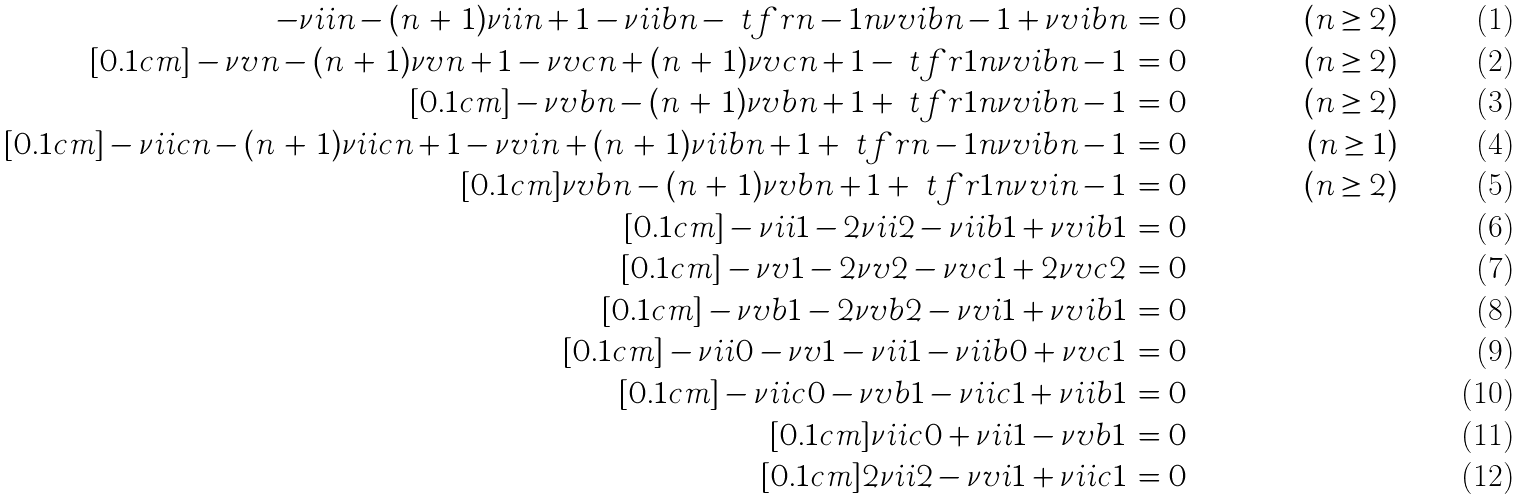<formula> <loc_0><loc_0><loc_500><loc_500>- \nu i i { n } - ( n \, + \, 1 ) \nu i i { n + 1 } - \nu i i b { n } - \ t f r { n - 1 } { n } \nu v i b { n - 1 } + \nu v i b { n } & \, = 0 & ( n \geq 2 ) \\ [ 0 . 1 c m ] - \nu v { n } - ( n \, + \, 1 ) \nu v { n + 1 } - \nu v c { n } + ( n \, + \, 1 ) \nu v c { n + 1 } - \ t f r { 1 } { n } \nu v i b { n - 1 } & \, = 0 & ( n \geq 2 ) \\ [ 0 . 1 c m ] - \nu v b { n } - ( n \, + \, 1 ) \nu v b { n + 1 } + \ t f r { 1 } { n } \nu v i b { n - 1 } & \, = 0 & ( n \geq 2 ) \\ [ 0 . 1 c m ] - \nu i i c { n } - ( n \, + \, 1 ) \nu i i c { n + 1 } - \nu v i { n } + ( n \, + \, 1 ) \nu i i b { n + 1 } + \ t f r { n - 1 } { n } \nu v i b { n - 1 } & \, = 0 & ( n \geq 1 ) \\ [ 0 . 1 c m ] \nu v b { n } - ( n \, + \, 1 ) \nu v b { n + 1 } + \ t f r { 1 } { n } \nu v i { n - 1 } & \, = 0 & ( n \geq 2 ) \\ [ 0 . 1 c m ] - \nu i i { 1 } - 2 \nu i i { 2 } - \nu i i b { 1 } + \nu v i b { 1 } & \, = 0 \\ [ 0 . 1 c m ] - \nu v { 1 } - 2 \nu v { 2 } - \nu v c { 1 } + 2 \nu v c { 2 } & \, = 0 \\ [ 0 . 1 c m ] - \nu v b { 1 } - 2 \nu v b { 2 } - \nu v i { 1 } + \nu v i b { 1 } & \, = 0 \\ [ 0 . 1 c m ] - \nu i i { 0 } - \nu v { 1 } - \nu i i { 1 } - \nu i i b { 0 } + \nu v c { 1 } & \, = 0 \\ [ 0 . 1 c m ] - \nu i i c { 0 } - \nu v b { 1 } - \nu i i c { 1 } + \nu i i b { 1 } & \, = 0 \\ [ 0 . 1 c m ] \nu i i c { 0 } + \nu i i { 1 } - \nu v b { 1 } & \, = 0 \\ [ 0 . 1 c m ] 2 \nu i i { 2 } - \nu v i { 1 } + \nu i i c { 1 } & \, = 0</formula> 